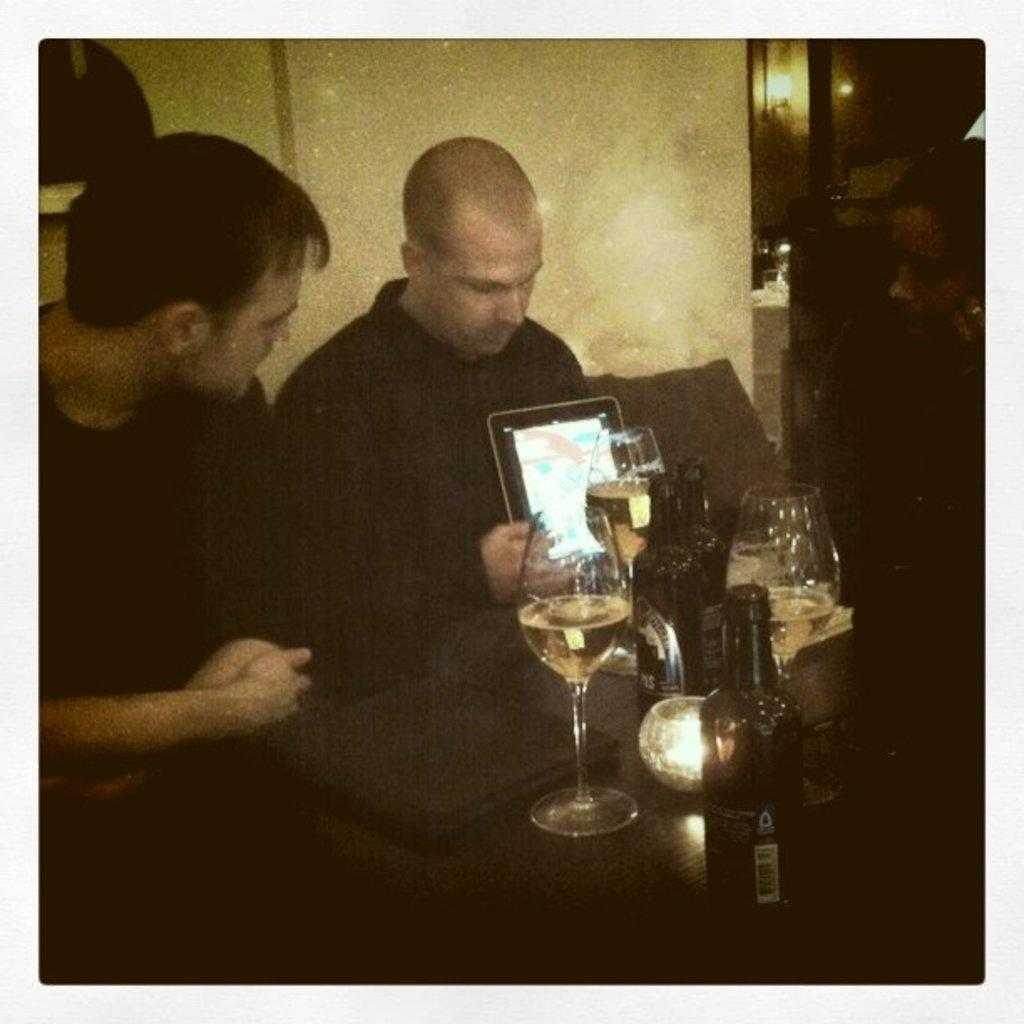How many people are in the image? There are two men and a woman in the image, making a total of three people. What are the individuals doing in the image? The individuals are sitting on chairs. What objects can be seen on the table in the image? There is a laptop, a glass, and a bottle on the table. Can you describe the lighting in the image? There is a light in the background of the image. Are there any airplanes visible in the image? No, there are no airplanes present in the image. Can you see any cobwebs in the image? No, there are no cobwebs visible in the image. 